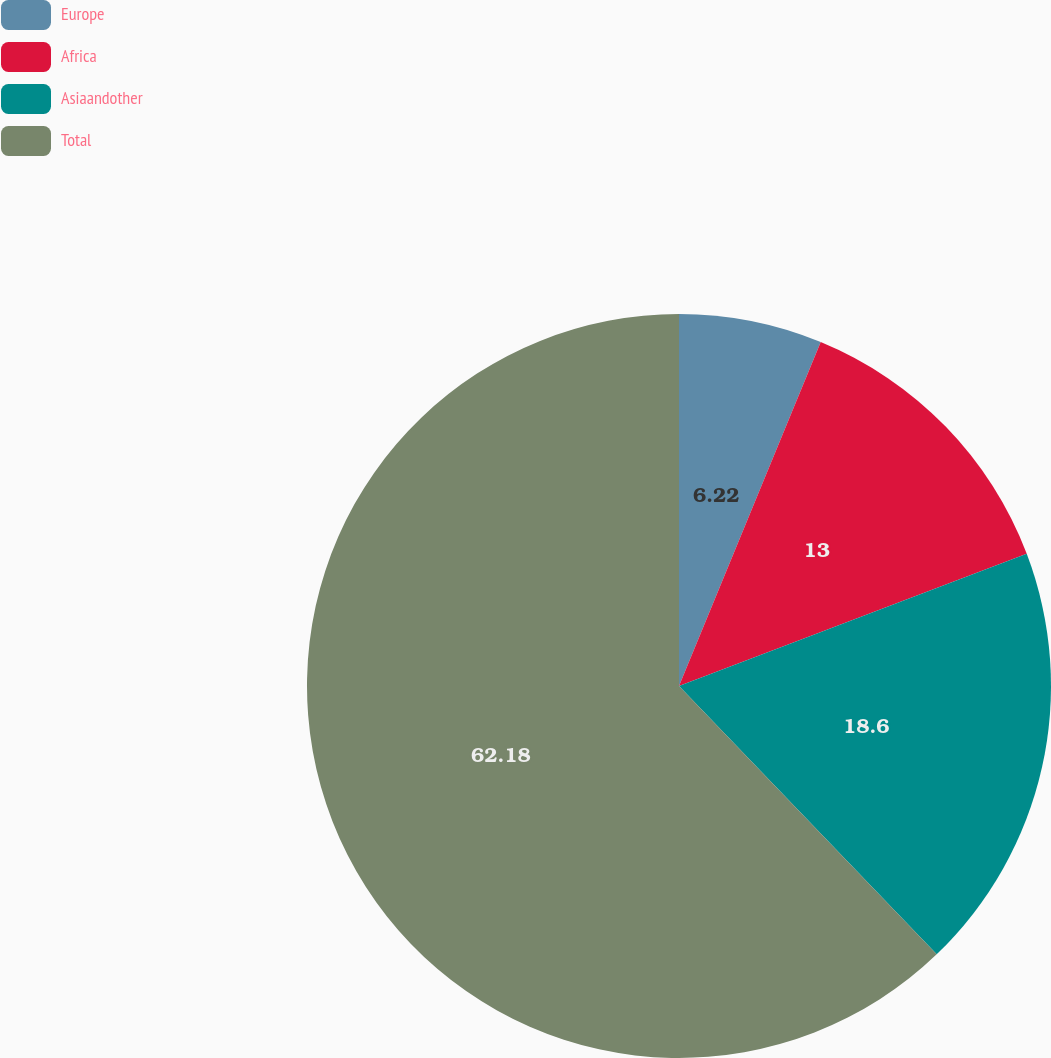<chart> <loc_0><loc_0><loc_500><loc_500><pie_chart><fcel>Europe<fcel>Africa<fcel>Asiaandother<fcel>Total<nl><fcel>6.22%<fcel>13.0%<fcel>18.6%<fcel>62.18%<nl></chart> 